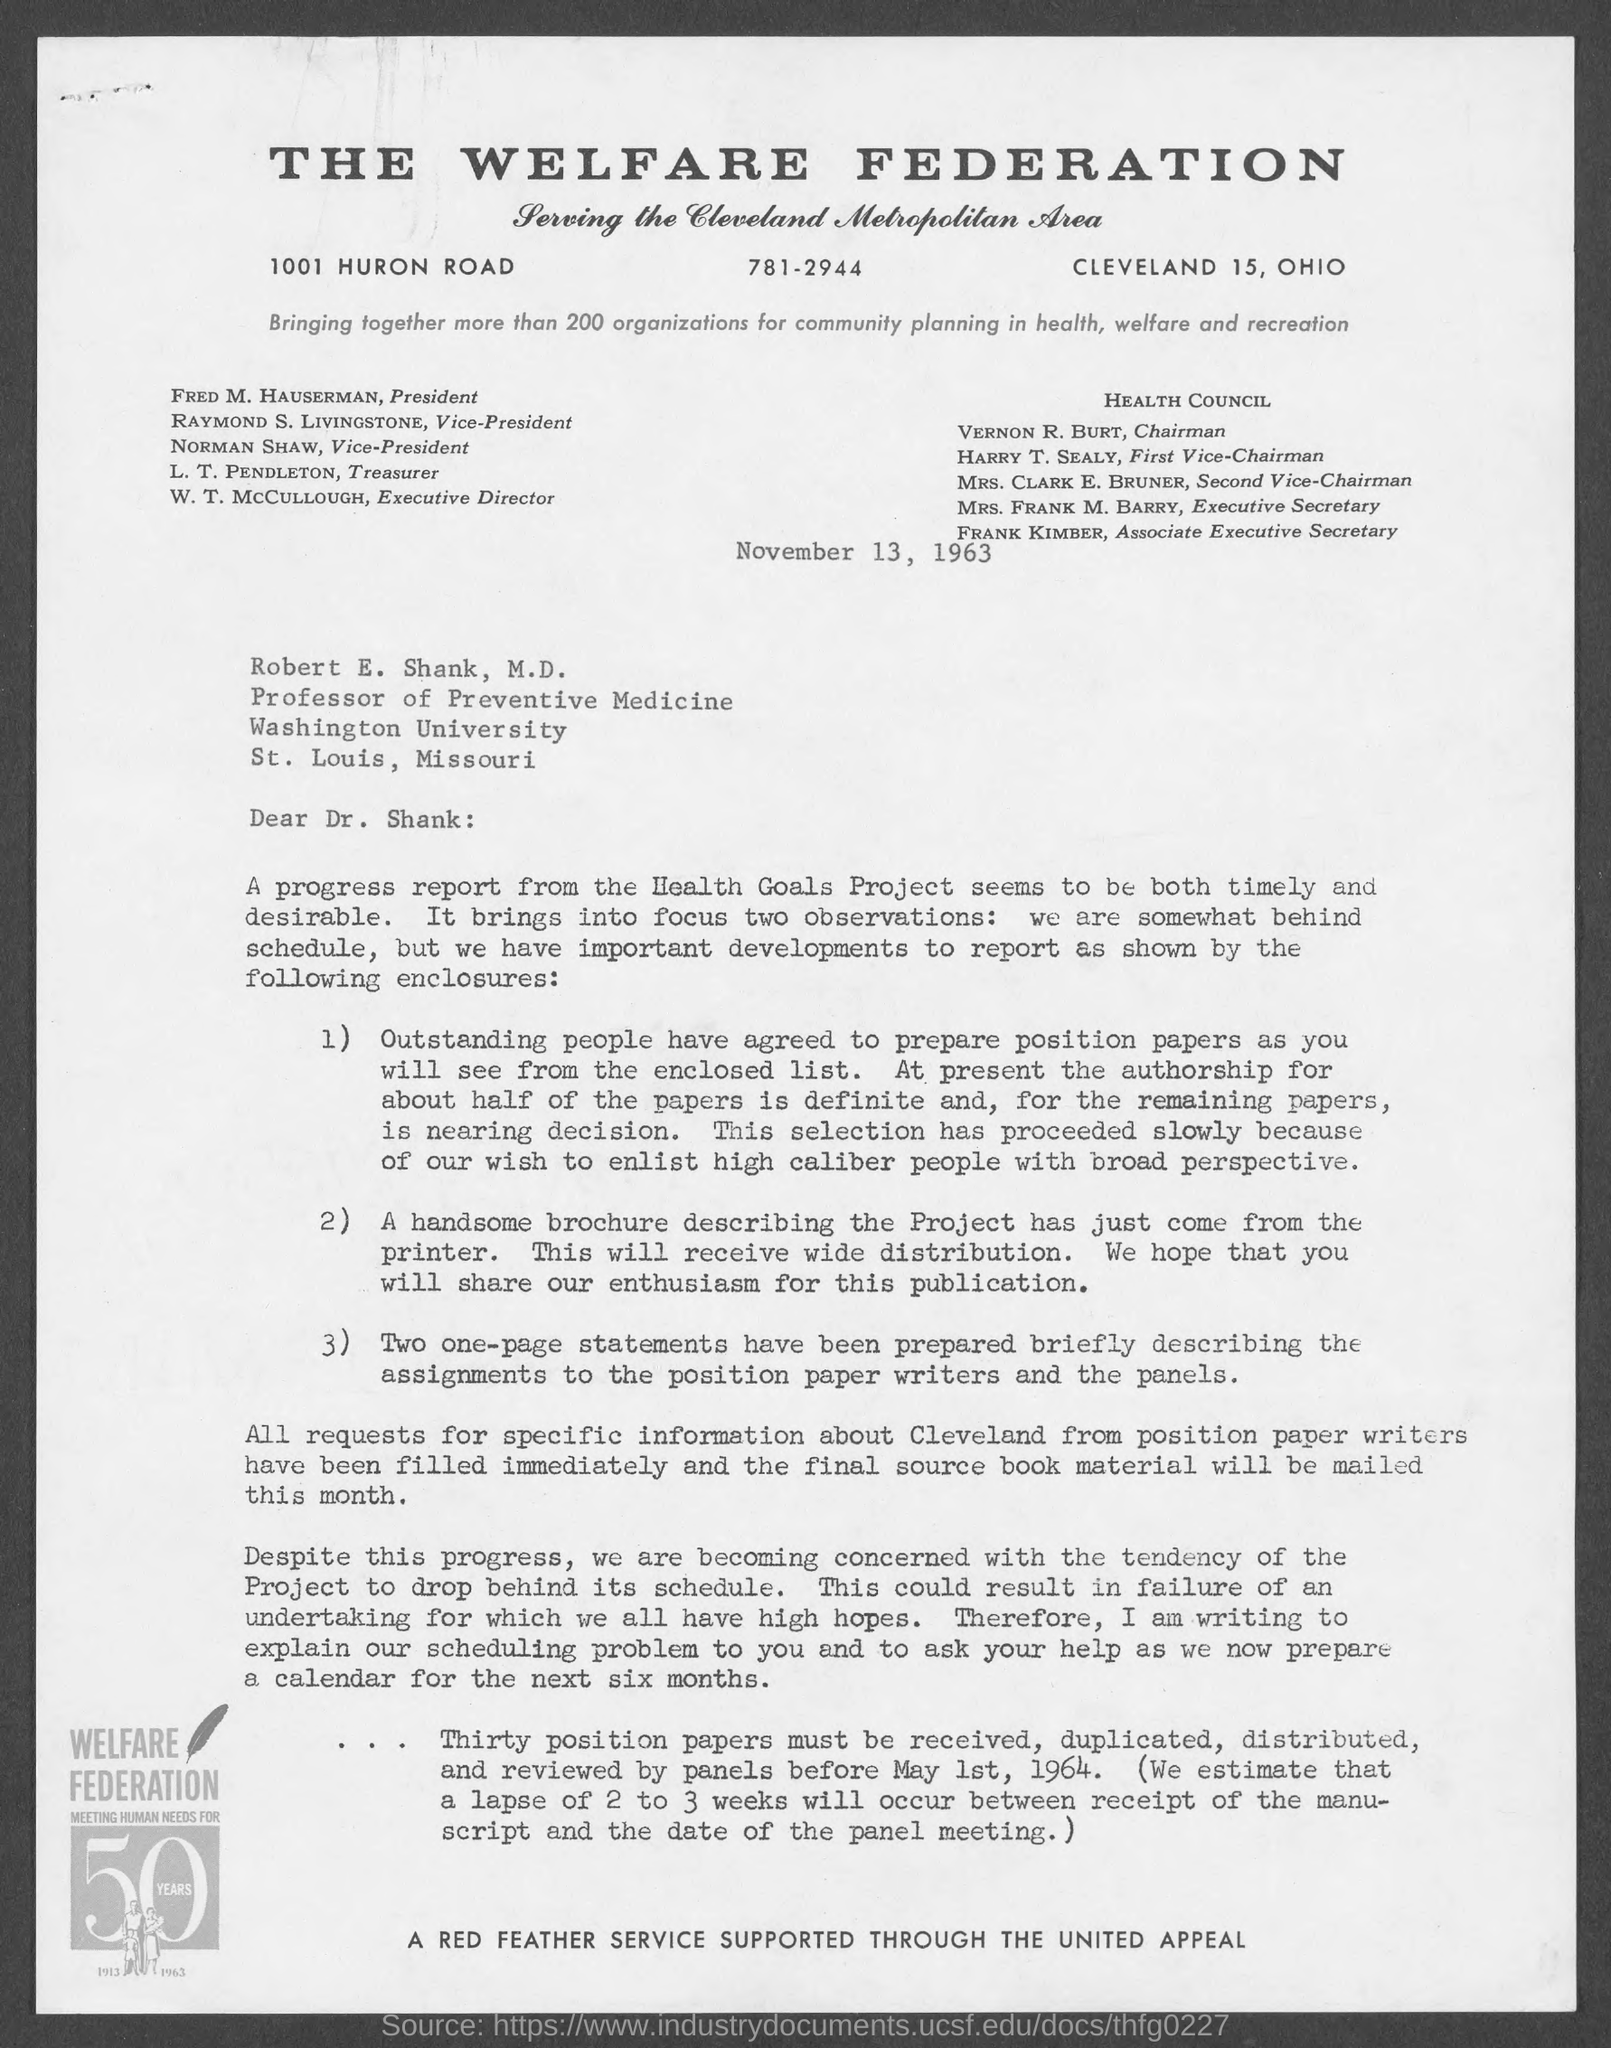Who is the Professor of Preventive Medicine?
Your response must be concise. Robert  E. Shank, M.D. Who is the President of the welfare federation?
Provide a succinct answer. Fred M. Hauserman. Who is the Associate Executive Secretary of health council?
Your answer should be compact. Frank Kimber. 